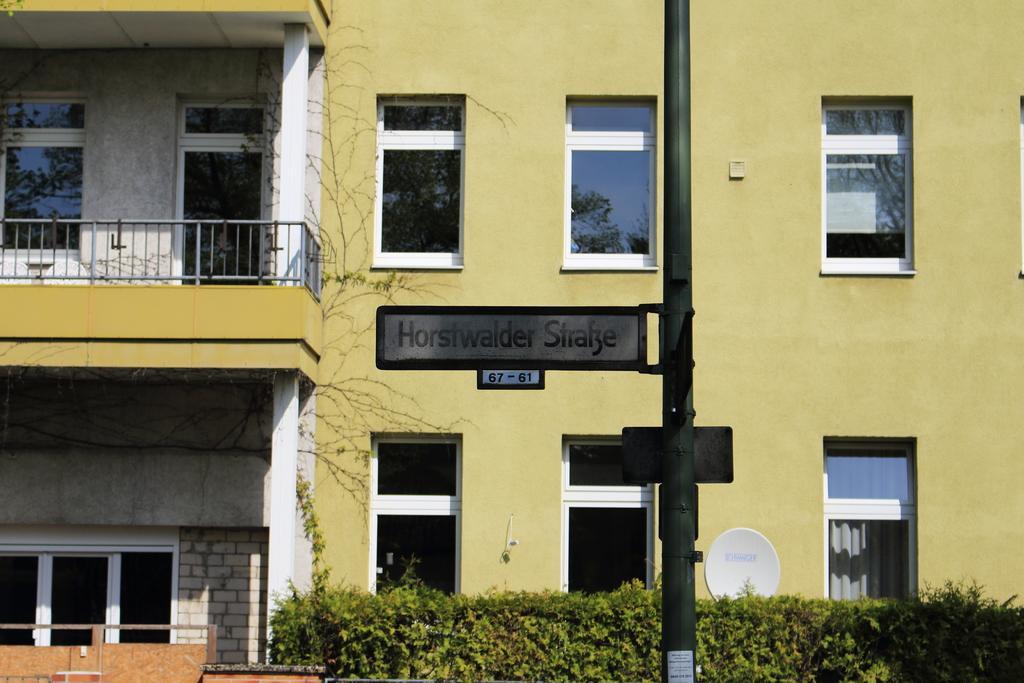Can you describe this image briefly? In this image we can see building, railings, windows, street pole, name board, bushes and creepers. 